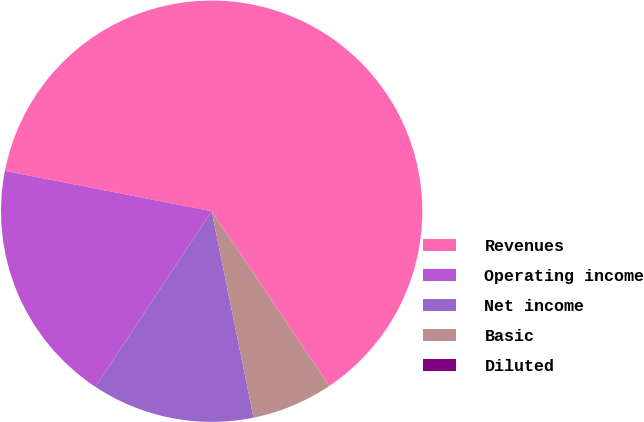<chart> <loc_0><loc_0><loc_500><loc_500><pie_chart><fcel>Revenues<fcel>Operating income<fcel>Net income<fcel>Basic<fcel>Diluted<nl><fcel>62.5%<fcel>18.75%<fcel>12.5%<fcel>6.25%<fcel>0.0%<nl></chart> 